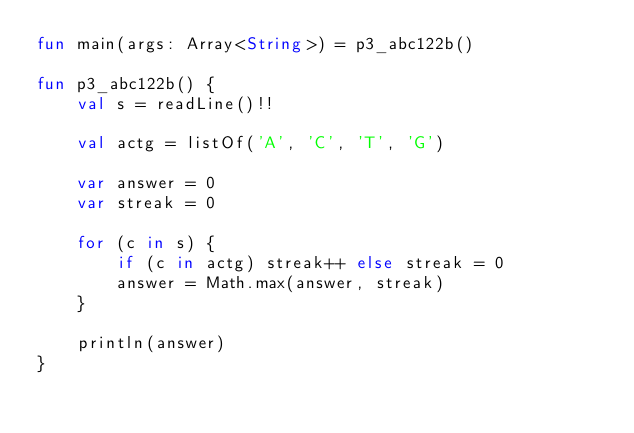Convert code to text. <code><loc_0><loc_0><loc_500><loc_500><_Kotlin_>fun main(args: Array<String>) = p3_abc122b()

fun p3_abc122b() {
    val s = readLine()!!

    val actg = listOf('A', 'C', 'T', 'G')

    var answer = 0
    var streak = 0

    for (c in s) {
        if (c in actg) streak++ else streak = 0
        answer = Math.max(answer, streak)
    }

    println(answer)
}
</code> 